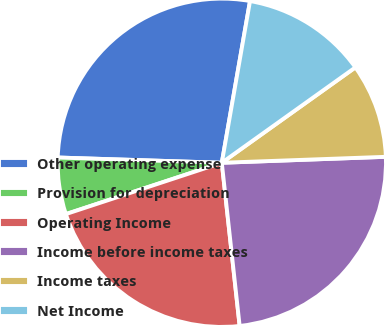<chart> <loc_0><loc_0><loc_500><loc_500><pie_chart><fcel>Other operating expense<fcel>Provision for depreciation<fcel>Operating Income<fcel>Income before income taxes<fcel>Income taxes<fcel>Net Income<nl><fcel>27.24%<fcel>5.57%<fcel>21.67%<fcel>23.84%<fcel>9.29%<fcel>12.38%<nl></chart> 